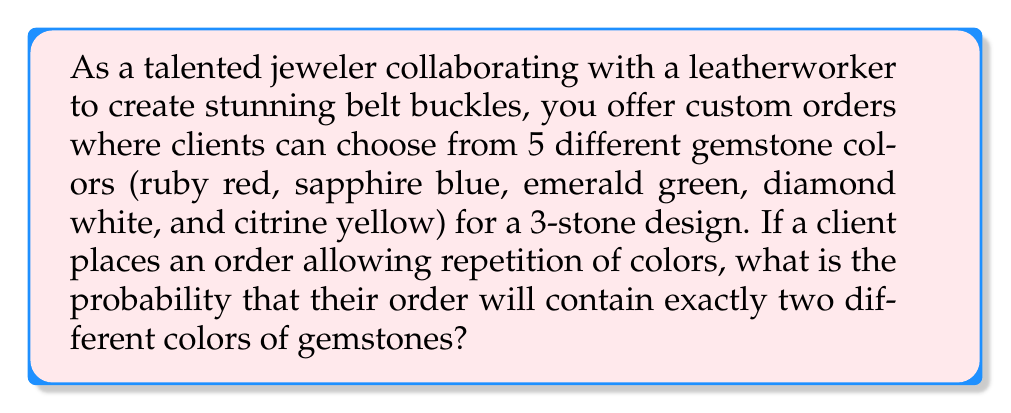Can you solve this math problem? To solve this problem, we need to use the concept of probability and combinations. Let's break it down step-by-step:

1) First, we need to calculate the total number of possible outcomes. With 5 colors and 3 stones, allowing repetition, we have:
   $$ \text{Total outcomes} = 5^3 = 125 $$

2) Now, we need to calculate the number of ways to have exactly two different colors. This can happen in two ways:
   a) Two stones of one color and one of another
   b) All three stones of the same color (which we'll subtract later)

3) For case (a), we can calculate it as follows:
   - Choose 2 colors from 5: $\binom{5}{2} = 10$ ways
   - Arrange these 2 colors in 3 positions: $3$ ways (AAB, ABA, BAA)
   
   So, the total number of outcomes for case (a) is:
   $$ 10 \times 3 = 30 $$

4) For case (b), we simply have 5 possibilities (all red, all blue, etc.)

5) Therefore, the total number of favorable outcomes is:
   $$ 30 - 5 = 25 $$

6) The probability is thus:
   $$ P(\text{exactly two colors}) = \frac{\text{favorable outcomes}}{\text{total outcomes}} = \frac{25}{125} = \frac{1}{5} = 0.2 $$
Answer: The probability that a custom order will contain exactly two different colors of gemstones is $\frac{1}{5}$ or $0.2$ or $20\%$. 